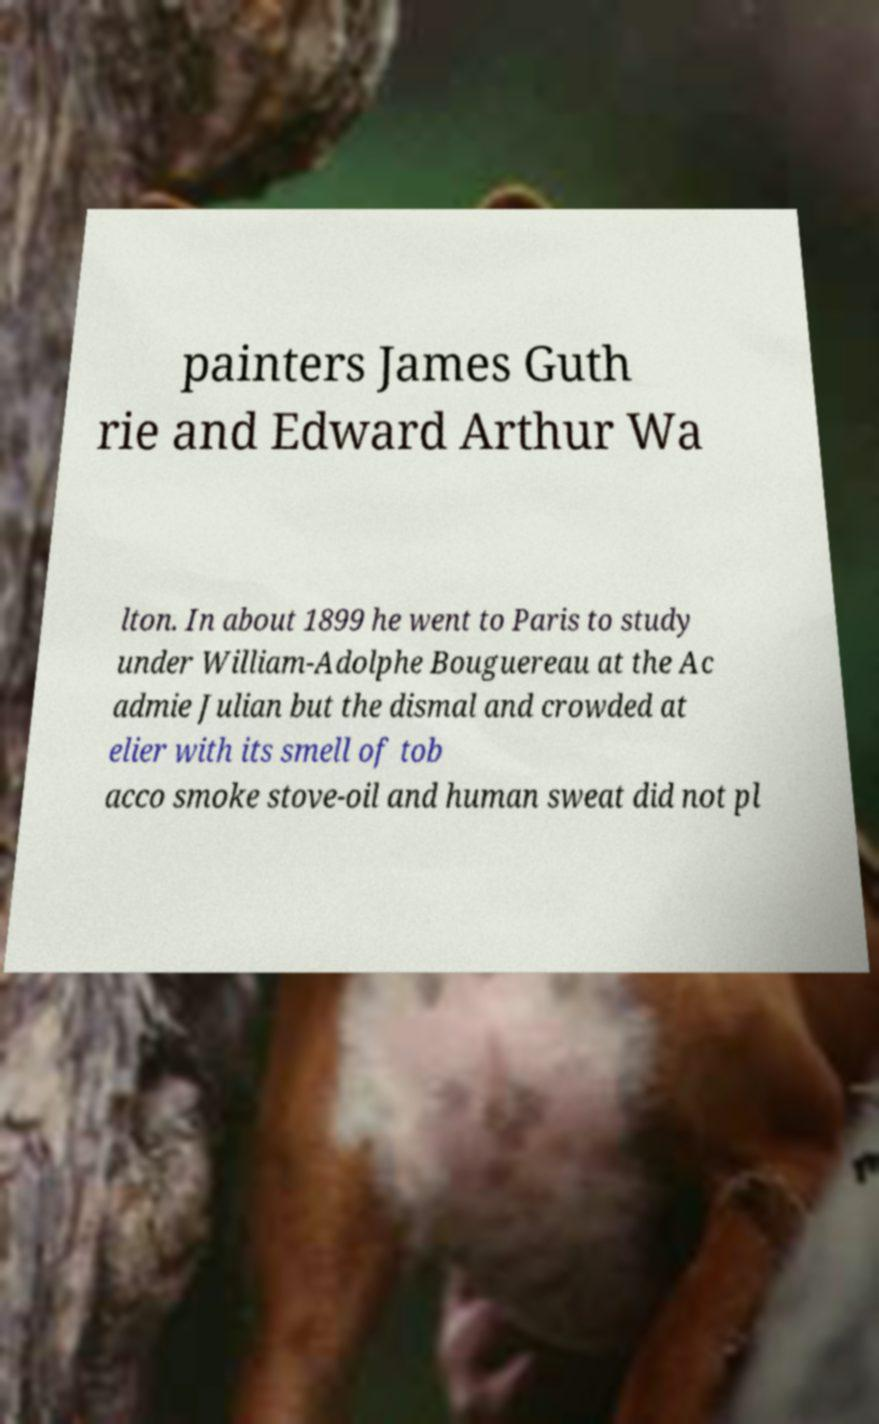Could you extract and type out the text from this image? painters James Guth rie and Edward Arthur Wa lton. In about 1899 he went to Paris to study under William-Adolphe Bouguereau at the Ac admie Julian but the dismal and crowded at elier with its smell of tob acco smoke stove-oil and human sweat did not pl 